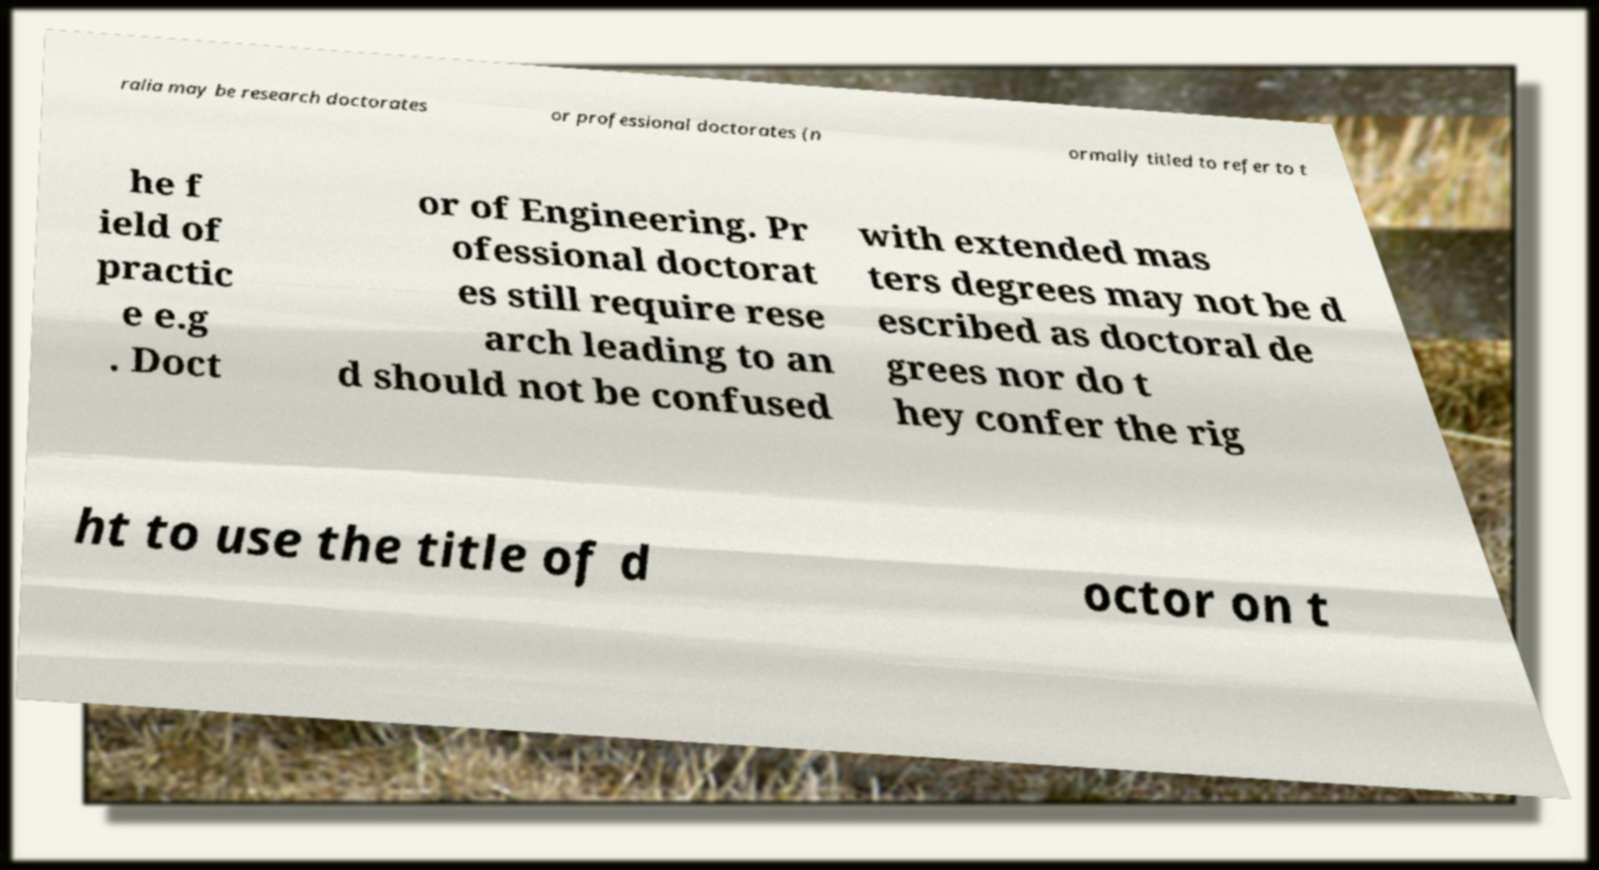Can you read and provide the text displayed in the image?This photo seems to have some interesting text. Can you extract and type it out for me? ralia may be research doctorates or professional doctorates (n ormally titled to refer to t he f ield of practic e e.g . Doct or of Engineering. Pr ofessional doctorat es still require rese arch leading to an d should not be confused with extended mas ters degrees may not be d escribed as doctoral de grees nor do t hey confer the rig ht to use the title of d octor on t 